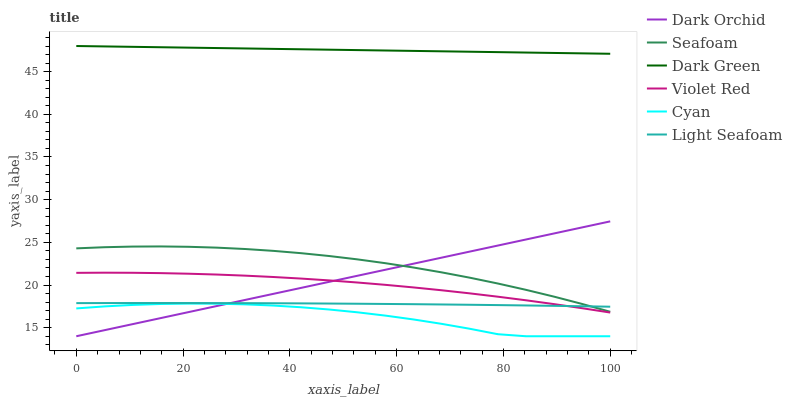Does Cyan have the minimum area under the curve?
Answer yes or no. Yes. Does Dark Green have the maximum area under the curve?
Answer yes or no. Yes. Does Seafoam have the minimum area under the curve?
Answer yes or no. No. Does Seafoam have the maximum area under the curve?
Answer yes or no. No. Is Dark Orchid the smoothest?
Answer yes or no. Yes. Is Cyan the roughest?
Answer yes or no. Yes. Is Seafoam the smoothest?
Answer yes or no. No. Is Seafoam the roughest?
Answer yes or no. No. Does Dark Orchid have the lowest value?
Answer yes or no. Yes. Does Seafoam have the lowest value?
Answer yes or no. No. Does Dark Green have the highest value?
Answer yes or no. Yes. Does Seafoam have the highest value?
Answer yes or no. No. Is Cyan less than Seafoam?
Answer yes or no. Yes. Is Dark Green greater than Cyan?
Answer yes or no. Yes. Does Dark Orchid intersect Seafoam?
Answer yes or no. Yes. Is Dark Orchid less than Seafoam?
Answer yes or no. No. Is Dark Orchid greater than Seafoam?
Answer yes or no. No. Does Cyan intersect Seafoam?
Answer yes or no. No. 